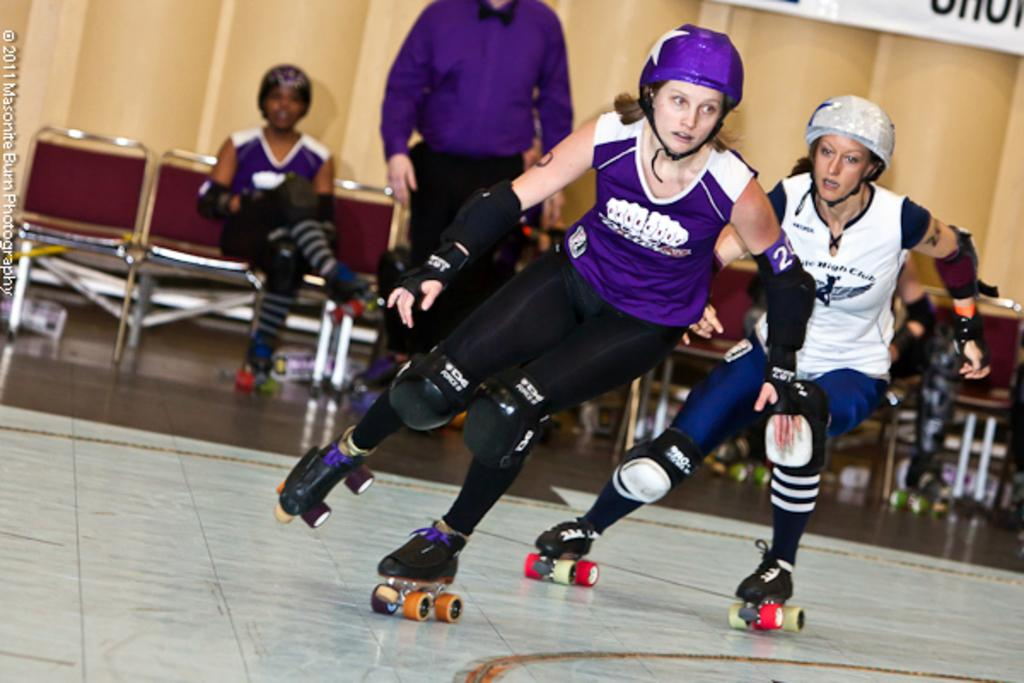What activity are the two persons in the image engaged in? The two persons are doing skating in the image. Can you describe the person standing behind the skaters? There is a man standing behind the skaters. What can be seen in the background of the image? There are people sitting on chairs and a wall visible in the background. What type of cabbage is being used as a prop in the skating performance? There is no cabbage present in the image, and it is not being used as a prop in the skating performance. 